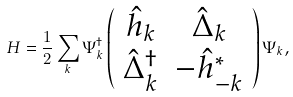<formula> <loc_0><loc_0><loc_500><loc_500>H = \frac { 1 } { 2 } \sum _ { k } \Psi ^ { \dagger } _ { k } \left ( \begin{array} { c c } \hat { h } _ { k } & \hat { \Delta } _ { k } \\ \hat { \Delta } ^ { \dagger } _ { k } & - \hat { h } ^ { * } _ { - k } \end{array} \right ) \Psi _ { k } ,</formula> 